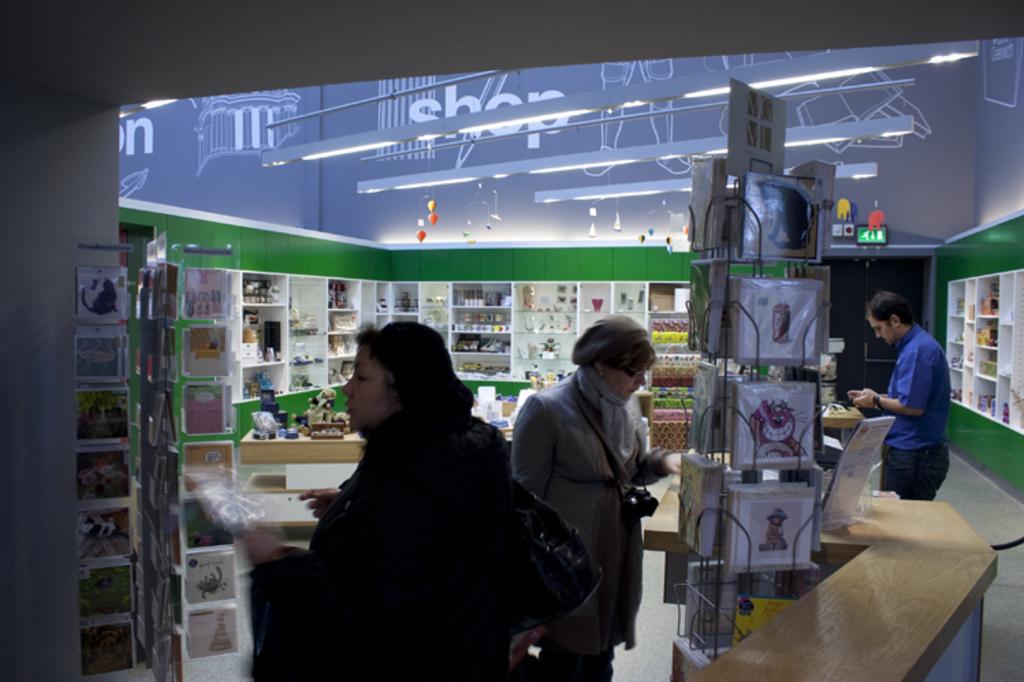What word is next to the legs?
Your answer should be compact. Unanswerable. 